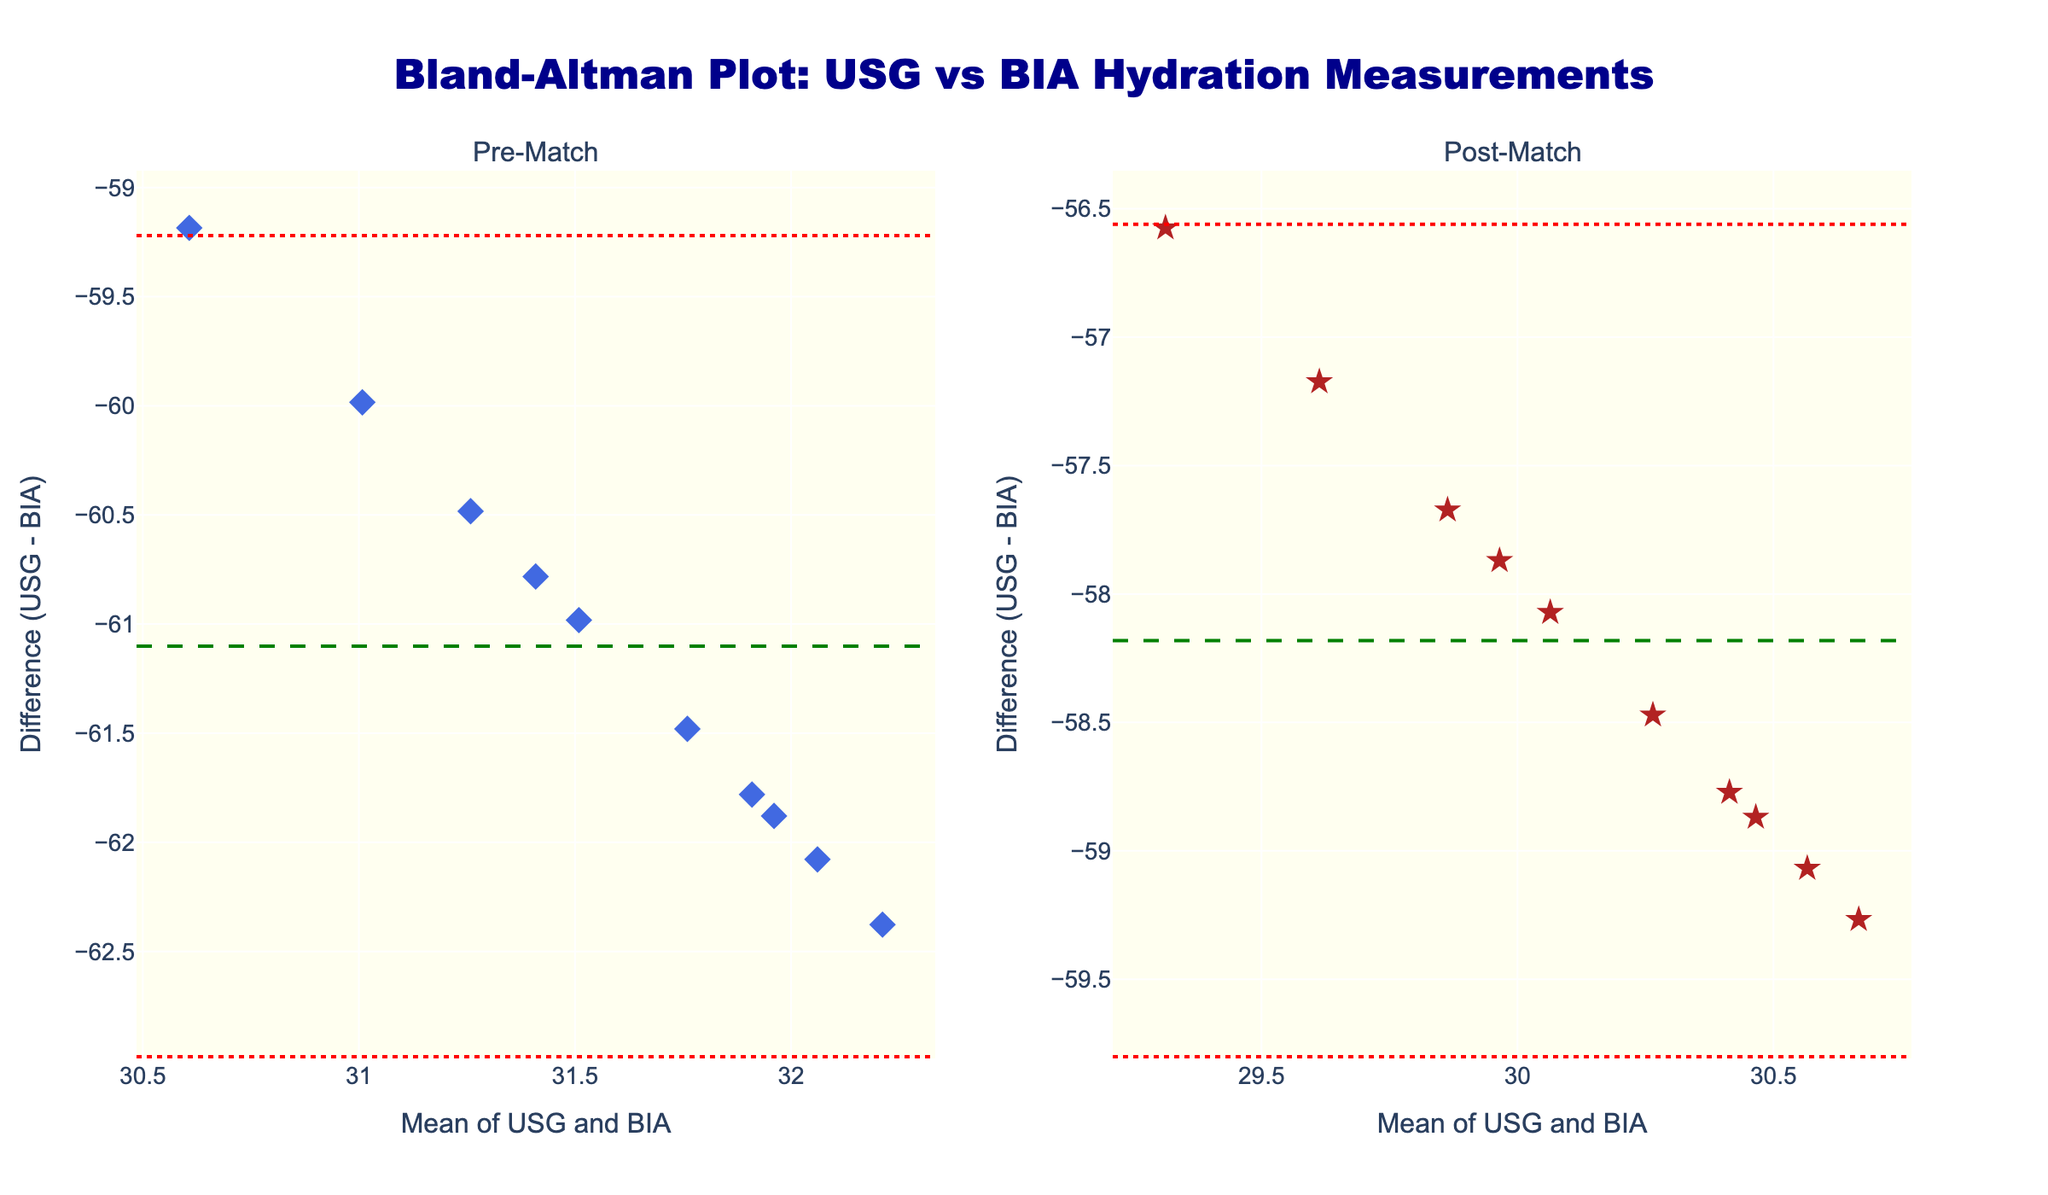What is the title of the plot? The title is prominently displayed at the top of the figure. It reads, "Bland-Altman Plot: USG vs BIA Hydration Measurements".
Answer: Bland-Altman Plot: USG vs BIA Hydration Measurements How many subplots are displayed in the figure? There are two subplot titles displayed "Pre-Match" and "Post-Match". This indicates that there are two subplots in the figure.
Answer: 2 What colors are used for the data points in the pre-match and post-match plots? The pre-match data points are colored royal blue while the post-match data points are colored firebrick.
Answer: Royal blue and firebrick What are the x-axis and y-axis labels of the plots? Both subplots share the same x-axis and y-axis labels. The x-axis is labeled "Mean of USG and BIA" and the y-axis is labeled "Difference (USG - BIA)".
Answer: Mean of USG and BIA; Difference (USG - BIA) How many data points are visible in each subplot? By counting the markers, it can be noticed that each subplot has 10 data points which correspond to the 10 players from the data provided.
Answer: 10 What is the green dashed line indicating in the pre-match plot? The green dashed line represents the mean difference between USG and BIA measurements before the match.
Answer: Mean difference Describe the pattern formed by the red dotted lines in both subplots. The red dotted lines are placed symmetrically around the green dashed line, indicating the upper and lower limits of agreement which are calculated as the mean difference plus and minus 1.96 times the standard deviation of the differences.
Answer: Limits of agreement How do the mean differences compare between the pre-match and post-match measurements? Comparing the green dashed lines in both subplots shows that the mean difference position in each subplot indicates whether the measurements pre and post-match are similar or different.
Answer: Needs subplot comparison Is there a noticeable difference in the spread of data points between pre-match and post-match plots? By observing the clustering and spread of the blue and red markers in both subplots, we can infer if the consistency of measurements has changed dramatically pre and post-match.
Answer: Depends on visual analysis Which measurement method (i.e., USG or BIA) tends to show higher values on average? The relationship between USG and BIA can be inferred by seeing which direction the difference values tend to lie (positive or negative) relative to the y-axis. If the differences are mostly positive, USG tends to be higher on average, and vice versa.
Answer: Visual observation needed 